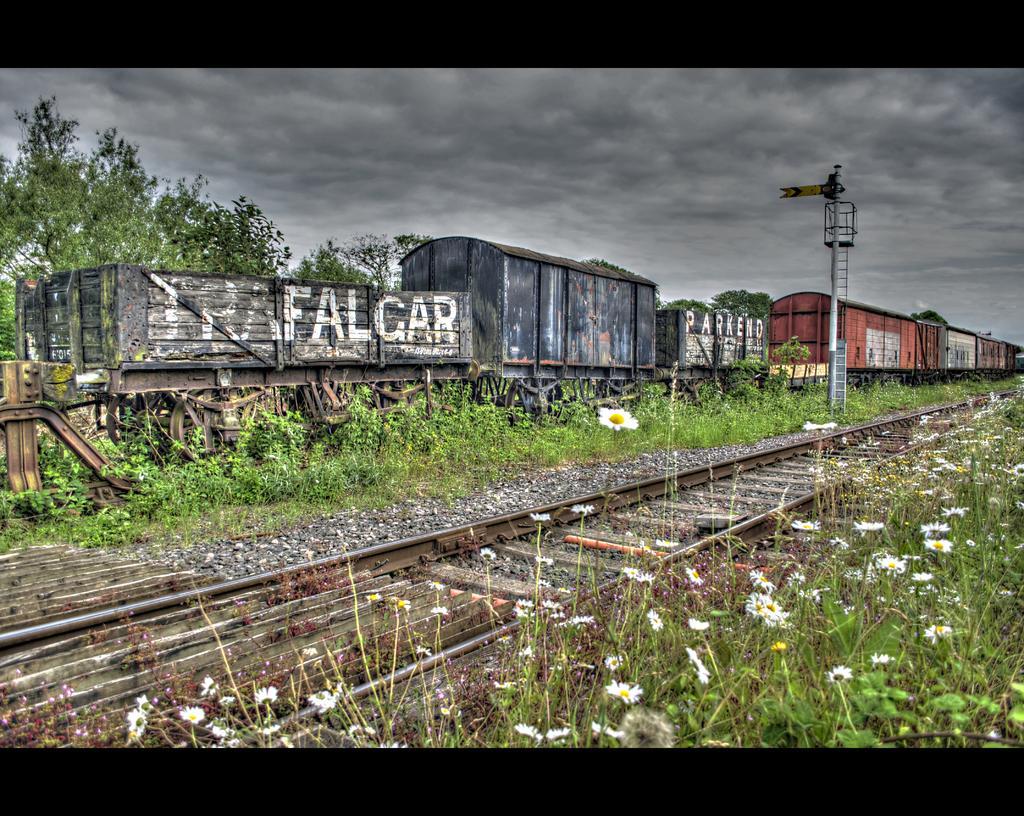How would you summarize this image in a sentence or two? In this image there is a empty track beside that there is a iron tower and flower plants on the other side there is a goods train and trees. 